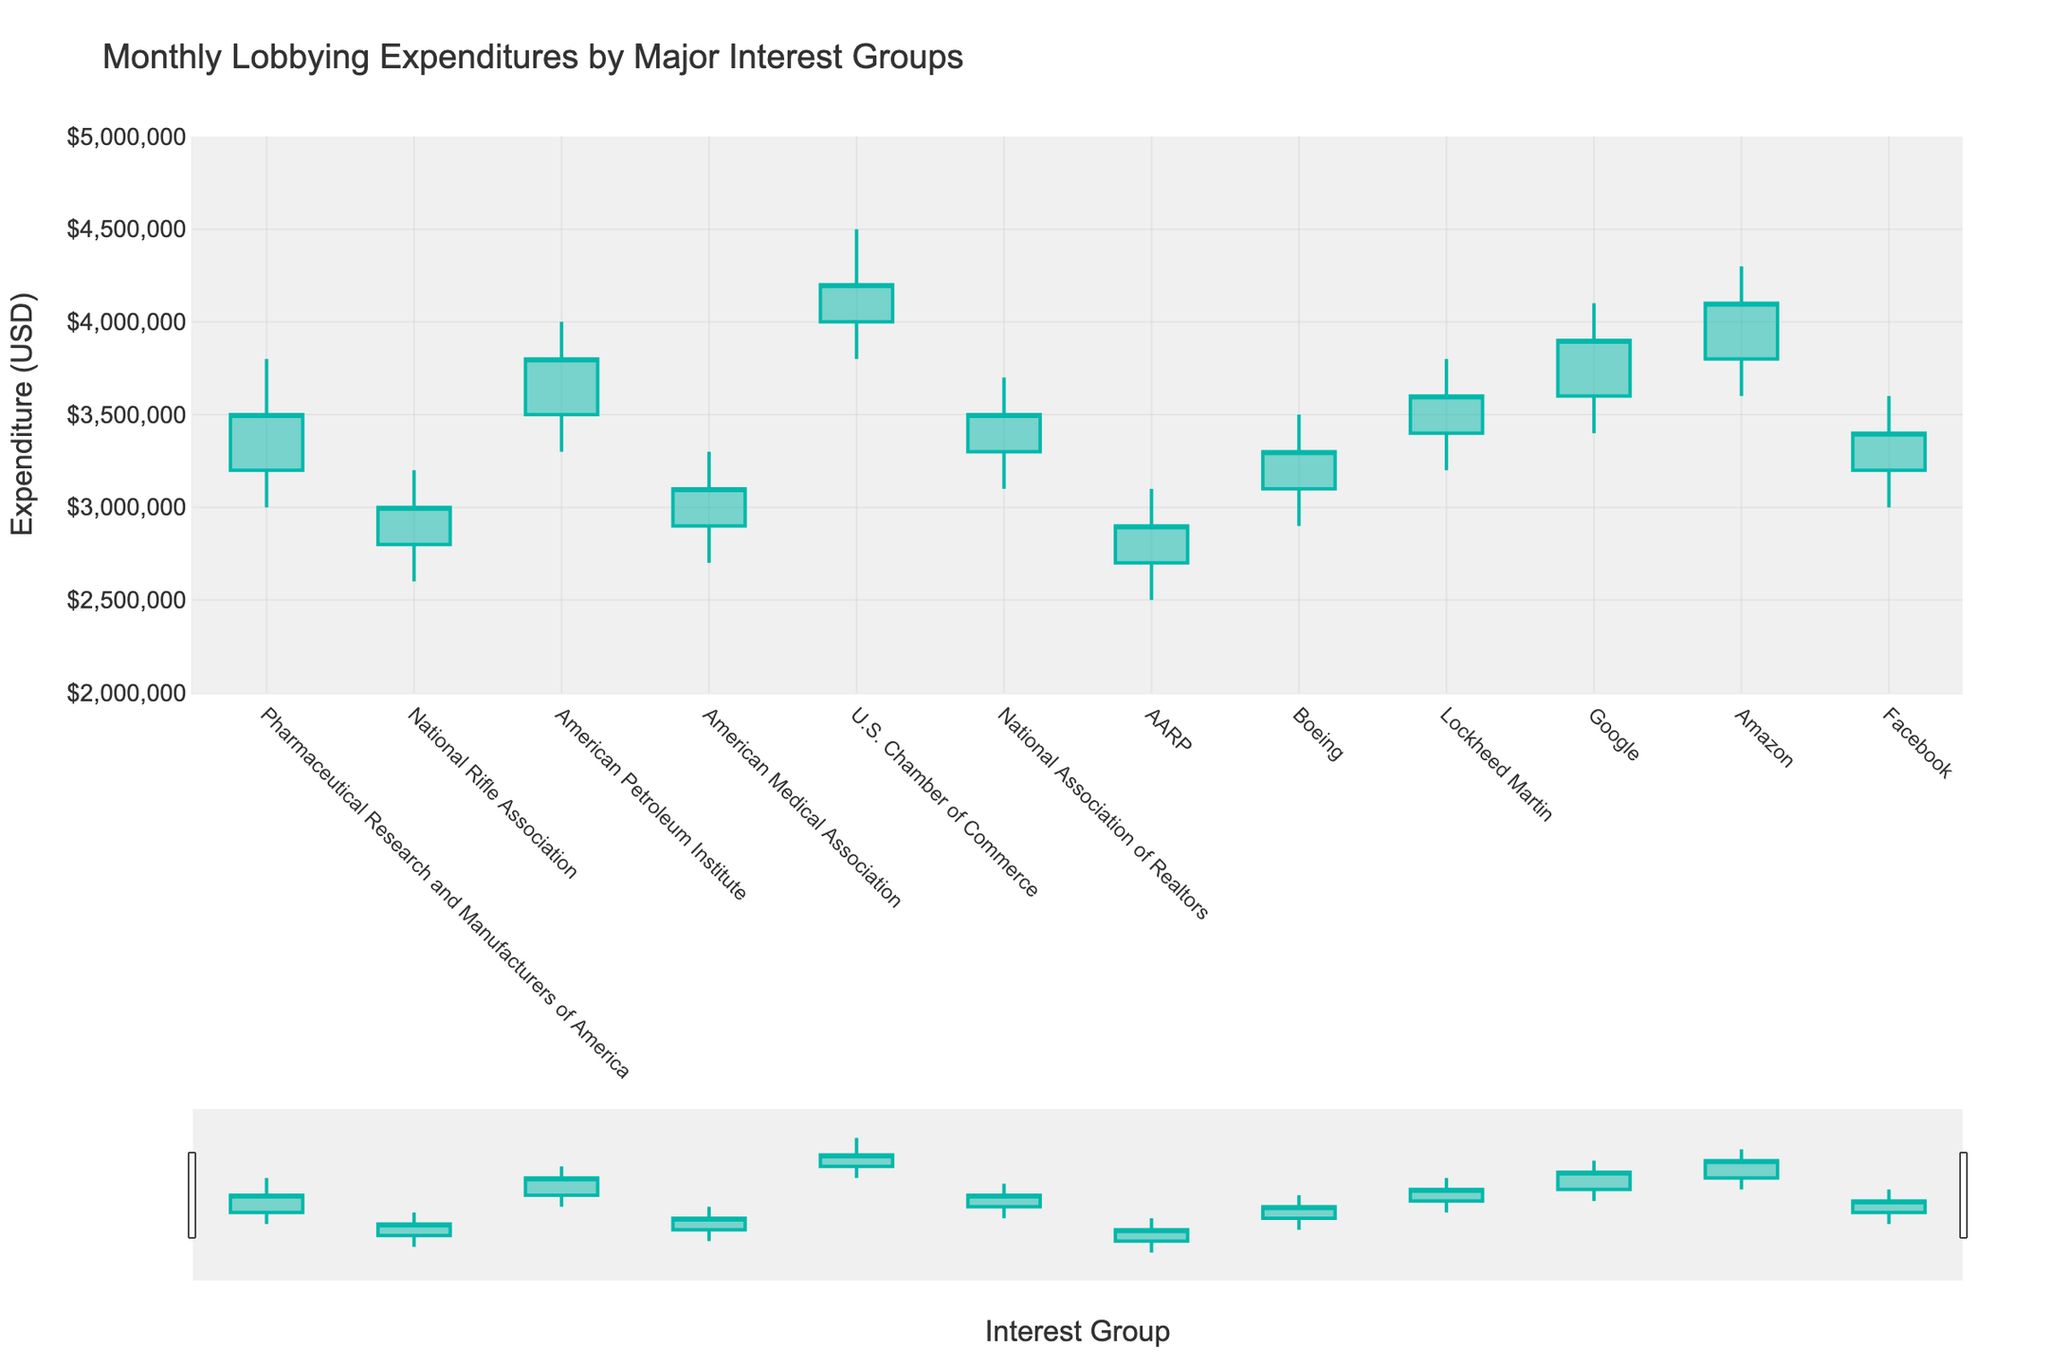What's the title of the figure? The title is usually located at the top of the figure and can be read directly.
Answer: Monthly Lobbying Expenditures by Major Interest Groups What does the y-axis represent? The label on the y-axis indicates what is being measured vertically. In this case, it shows the expenditure in USD.
Answer: Expenditure (USD) Which interest group has the highest closing expenditure? By looking for the highest position of the "Close" value along the y-axis, we can identify that Amazon has the highest closing expenditure as its data point reaches up to 4,100,000 USD.
Answer: Amazon In which month did the U.S. Chamber of Commerce experience its highest expenditure? Find the candlestick for the U.S. Chamber of Commerce and locate the highest point of the "High" value, which is in May.
Answer: May Compare the opening expenditure of Google and Facebook. Which one is higher? Find the opening values for both Google and Facebook and compare them. Google's opening expenditure is higher at $3,600,000 compared to Facebook's $3,200,000.
Answer: Google What is the range of expenditures for Boeings (difference between highest and lowest values)? Subtract the lowest expenditure value (Low) from the highest expenditure value (High) for Boeing. This is $3,500,000 - $2,900,000 = $600,000.
Answer: $600,000 Which interest group had the lowest low value, and which month did it occur? Find the interest group with the lowest data point on the y-axis. The lowest low value is for AARP in July at $2,500,000.
Answer: AARP, July Between Jan and Dec, which group's expenditure changed the most from the open to close? Calculate the absolute difference between the open and close values for each group, then identify the largest difference. U.S. Chamber of Commerce in May has a difference of $400,000.
Answer: U.S. Chamber of Commerce How many interest groups had a closing expenditure above $3,500,000? Count the number of cases where the closing expenditure value is above $3,500,000 by inspecting each interest group's candlestick. Four groups meet this criterion (American Petroleum Institute, U.S. Chamber of Commerce, Google, Amazon).
Answer: 4 What is the average closing expenditure value for all interest groups? Sum the close values for all the interest groups and divide by the number of interest groups. The sum of close values is $38,660,000, and there are 12 groups. So, the average is $38,660,000 / 12 = $3,221,666.67.
Answer: $3,221,666.67 